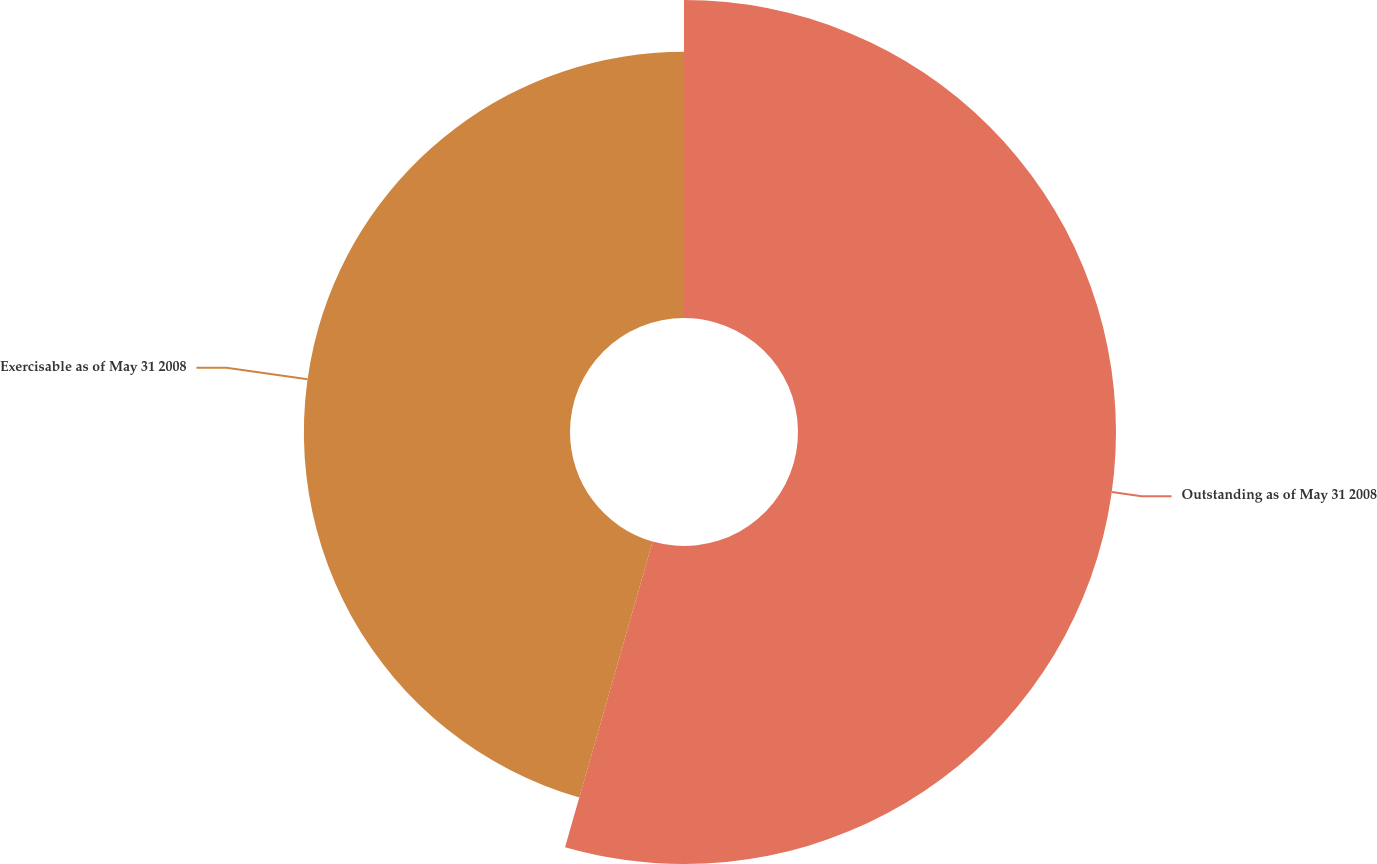<chart> <loc_0><loc_0><loc_500><loc_500><pie_chart><fcel>Outstanding as of May 31 2008<fcel>Exercisable as of May 31 2008<nl><fcel>54.44%<fcel>45.56%<nl></chart> 